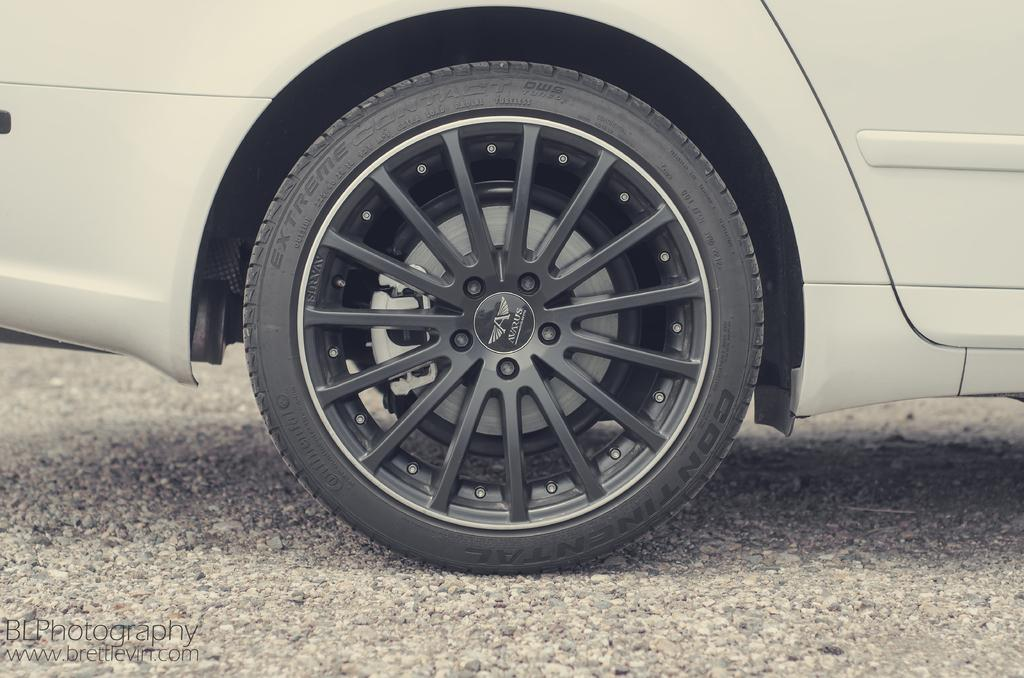What object is present in the image that is related to a car? There is a car tyre in the image. Where is the car located in the image? The car is standing on the road in the image. What type of net can be seen hanging from the car in the image? There is no net present in the image; it only features a car tyre and the car standing on the road. 